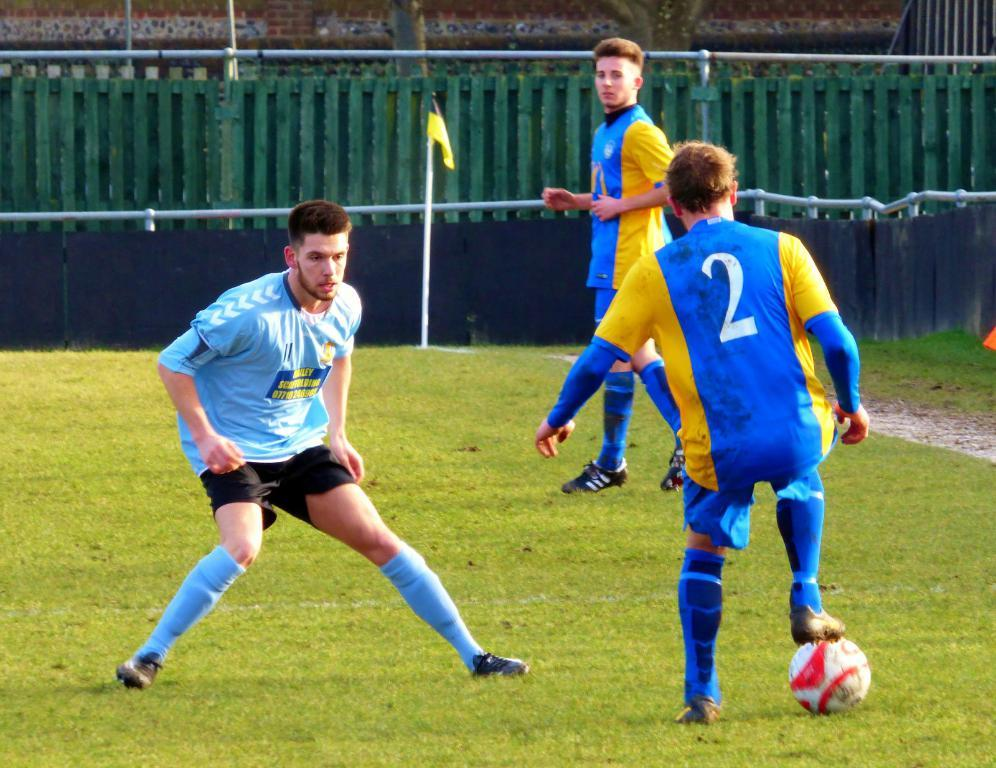<image>
Provide a brief description of the given image. The young man on the soccer team sponsored by Bailey Scaffolding waits carefully as the number 2 player on the opposing team prepares to kick the ball. 